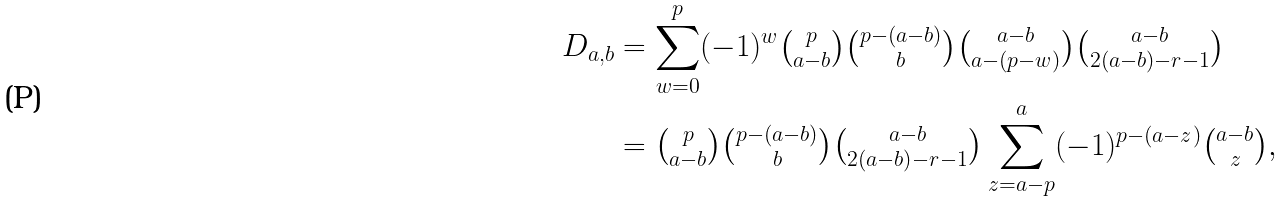Convert formula to latex. <formula><loc_0><loc_0><loc_500><loc_500>D _ { a , b } & = \sum _ { w = 0 } ^ { p } ( - 1 ) ^ { w } \tbinom p { a - b } \tbinom { p - ( a - b ) } { b } \tbinom { a - b } { a - ( p - w ) } \tbinom { a - b } { 2 ( a - b ) - r - 1 } \\ & = \tbinom p { a - b } \tbinom { p - ( a - b ) } { b } \tbinom { a - b } { 2 ( a - b ) - r - 1 } \sum _ { z = a - p } ^ { a } ( - 1 ) ^ { p - ( a - z ) } \tbinom { a - b } { z } ,</formula> 